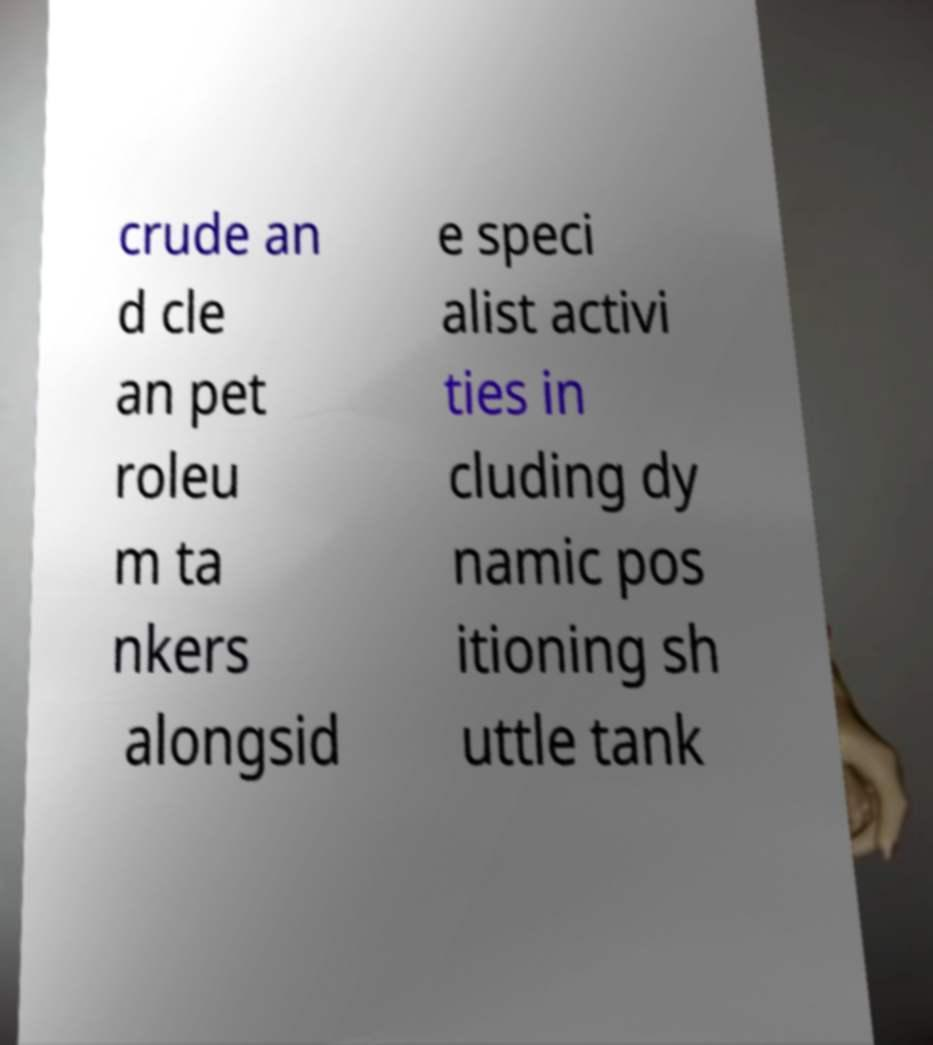Can you accurately transcribe the text from the provided image for me? crude an d cle an pet roleu m ta nkers alongsid e speci alist activi ties in cluding dy namic pos itioning sh uttle tank 